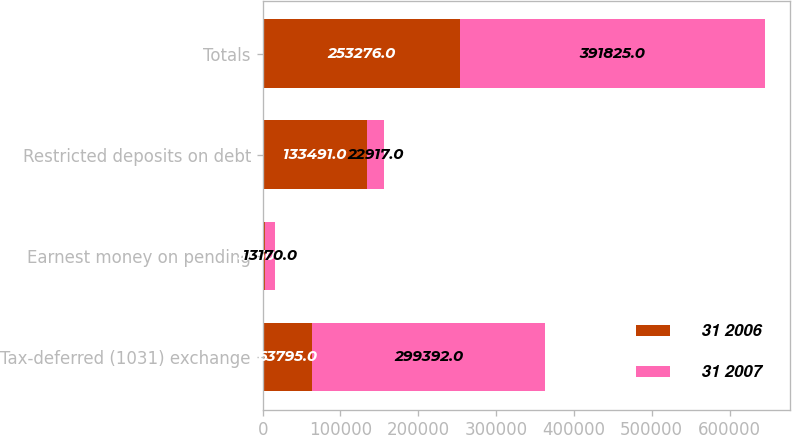Convert chart to OTSL. <chart><loc_0><loc_0><loc_500><loc_500><stacked_bar_chart><ecel><fcel>Tax-deferred (1031) exchange<fcel>Earnest money on pending<fcel>Restricted deposits on debt<fcel>Totals<nl><fcel>31 2006<fcel>63795<fcel>3050<fcel>133491<fcel>253276<nl><fcel>31 2007<fcel>299392<fcel>13170<fcel>22917<fcel>391825<nl></chart> 